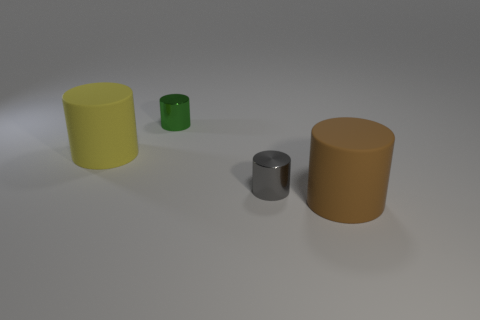Subtract all tiny green shiny cylinders. How many cylinders are left? 3 Subtract all yellow cylinders. How many cylinders are left? 3 Add 1 gray metallic things. How many objects exist? 5 Subtract 3 cylinders. How many cylinders are left? 1 Subtract all gray blocks. How many gray cylinders are left? 1 Subtract all big green balls. Subtract all big matte things. How many objects are left? 2 Add 1 small green metallic cylinders. How many small green metallic cylinders are left? 2 Add 4 big brown matte cylinders. How many big brown matte cylinders exist? 5 Subtract 0 gray balls. How many objects are left? 4 Subtract all cyan cylinders. Subtract all brown cubes. How many cylinders are left? 4 